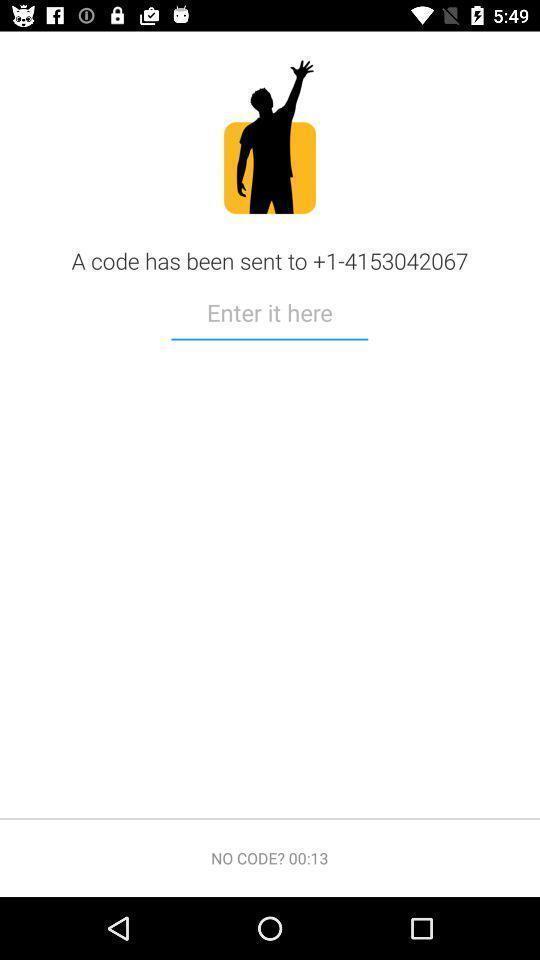Give me a summary of this screen capture. Page with a text field asking for a verification code. 